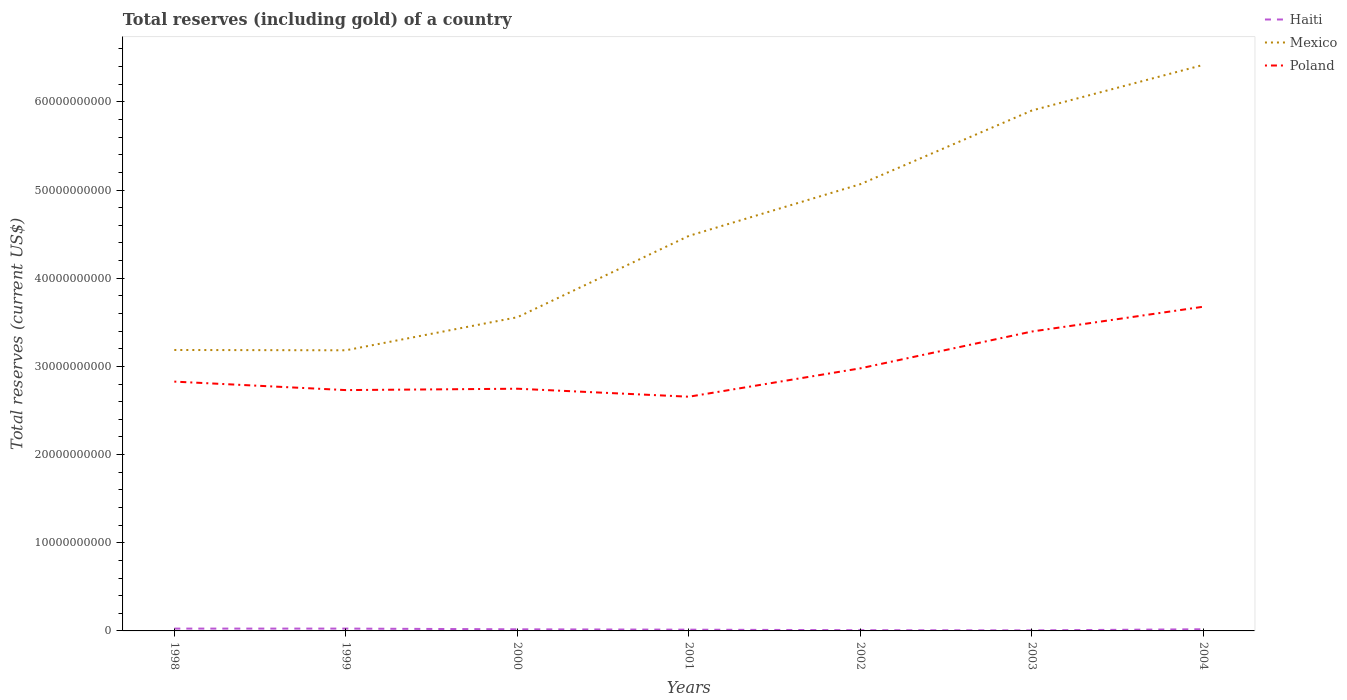Does the line corresponding to Haiti intersect with the line corresponding to Poland?
Make the answer very short. No. Is the number of lines equal to the number of legend labels?
Provide a succinct answer. Yes. Across all years, what is the maximum total reserves (including gold) in Mexico?
Your response must be concise. 3.18e+1. What is the total total reserves (including gold) in Haiti in the graph?
Give a very brief answer. 1.20e+08. What is the difference between the highest and the second highest total reserves (including gold) in Haiti?
Your answer should be very brief. 2.02e+08. Is the total reserves (including gold) in Mexico strictly greater than the total reserves (including gold) in Poland over the years?
Keep it short and to the point. No. How many years are there in the graph?
Your response must be concise. 7. Does the graph contain grids?
Offer a very short reply. No. Where does the legend appear in the graph?
Your response must be concise. Top right. What is the title of the graph?
Provide a succinct answer. Total reserves (including gold) of a country. What is the label or title of the X-axis?
Offer a very short reply. Years. What is the label or title of the Y-axis?
Keep it short and to the point. Total reserves (current US$). What is the Total reserves (current US$) in Haiti in 1998?
Offer a terse response. 2.64e+08. What is the Total reserves (current US$) of Mexico in 1998?
Your answer should be very brief. 3.19e+1. What is the Total reserves (current US$) in Poland in 1998?
Your response must be concise. 2.83e+1. What is the Total reserves (current US$) of Haiti in 1999?
Provide a succinct answer. 2.64e+08. What is the Total reserves (current US$) of Mexico in 1999?
Give a very brief answer. 3.18e+1. What is the Total reserves (current US$) of Poland in 1999?
Give a very brief answer. 2.73e+1. What is the Total reserves (current US$) in Haiti in 2000?
Ensure brevity in your answer.  1.83e+08. What is the Total reserves (current US$) in Mexico in 2000?
Give a very brief answer. 3.56e+1. What is the Total reserves (current US$) of Poland in 2000?
Keep it short and to the point. 2.75e+1. What is the Total reserves (current US$) in Haiti in 2001?
Offer a terse response. 1.42e+08. What is the Total reserves (current US$) of Mexico in 2001?
Ensure brevity in your answer.  4.48e+1. What is the Total reserves (current US$) of Poland in 2001?
Provide a short and direct response. 2.66e+1. What is the Total reserves (current US$) of Haiti in 2002?
Your answer should be compact. 8.22e+07. What is the Total reserves (current US$) of Mexico in 2002?
Provide a short and direct response. 5.07e+1. What is the Total reserves (current US$) in Poland in 2002?
Provide a short and direct response. 2.98e+1. What is the Total reserves (current US$) of Haiti in 2003?
Give a very brief answer. 6.26e+07. What is the Total reserves (current US$) in Mexico in 2003?
Keep it short and to the point. 5.90e+1. What is the Total reserves (current US$) in Poland in 2003?
Give a very brief answer. 3.40e+1. What is the Total reserves (current US$) of Haiti in 2004?
Provide a short and direct response. 1.89e+08. What is the Total reserves (current US$) in Mexico in 2004?
Keep it short and to the point. 6.42e+1. What is the Total reserves (current US$) in Poland in 2004?
Offer a terse response. 3.68e+1. Across all years, what is the maximum Total reserves (current US$) in Haiti?
Your response must be concise. 2.64e+08. Across all years, what is the maximum Total reserves (current US$) of Mexico?
Your answer should be very brief. 6.42e+1. Across all years, what is the maximum Total reserves (current US$) in Poland?
Provide a succinct answer. 3.68e+1. Across all years, what is the minimum Total reserves (current US$) in Haiti?
Provide a succinct answer. 6.26e+07. Across all years, what is the minimum Total reserves (current US$) of Mexico?
Your answer should be very brief. 3.18e+1. Across all years, what is the minimum Total reserves (current US$) in Poland?
Your response must be concise. 2.66e+1. What is the total Total reserves (current US$) of Haiti in the graph?
Provide a succinct answer. 1.19e+09. What is the total Total reserves (current US$) of Mexico in the graph?
Provide a short and direct response. 3.18e+11. What is the total Total reserves (current US$) of Poland in the graph?
Provide a succinct answer. 2.10e+11. What is the difference between the Total reserves (current US$) of Haiti in 1998 and that in 1999?
Your answer should be very brief. -4.88e+05. What is the difference between the Total reserves (current US$) of Mexico in 1998 and that in 1999?
Provide a short and direct response. 3.48e+07. What is the difference between the Total reserves (current US$) in Poland in 1998 and that in 1999?
Your response must be concise. 9.62e+08. What is the difference between the Total reserves (current US$) in Haiti in 1998 and that in 2000?
Keep it short and to the point. 8.14e+07. What is the difference between the Total reserves (current US$) in Mexico in 1998 and that in 2000?
Keep it short and to the point. -3.71e+09. What is the difference between the Total reserves (current US$) of Poland in 1998 and that in 2000?
Ensure brevity in your answer.  8.07e+08. What is the difference between the Total reserves (current US$) in Haiti in 1998 and that in 2001?
Offer a terse response. 1.22e+08. What is the difference between the Total reserves (current US$) in Mexico in 1998 and that in 2001?
Provide a short and direct response. -1.29e+1. What is the difference between the Total reserves (current US$) of Poland in 1998 and that in 2001?
Your answer should be very brief. 1.71e+09. What is the difference between the Total reserves (current US$) in Haiti in 1998 and that in 2002?
Your answer should be very brief. 1.82e+08. What is the difference between the Total reserves (current US$) in Mexico in 1998 and that in 2002?
Offer a terse response. -1.88e+1. What is the difference between the Total reserves (current US$) of Poland in 1998 and that in 2002?
Give a very brief answer. -1.51e+09. What is the difference between the Total reserves (current US$) in Haiti in 1998 and that in 2003?
Your answer should be compact. 2.01e+08. What is the difference between the Total reserves (current US$) of Mexico in 1998 and that in 2003?
Your answer should be compact. -2.72e+1. What is the difference between the Total reserves (current US$) of Poland in 1998 and that in 2003?
Your answer should be very brief. -5.68e+09. What is the difference between the Total reserves (current US$) in Haiti in 1998 and that in 2004?
Make the answer very short. 7.49e+07. What is the difference between the Total reserves (current US$) of Mexico in 1998 and that in 2004?
Make the answer very short. -3.23e+1. What is the difference between the Total reserves (current US$) in Poland in 1998 and that in 2004?
Ensure brevity in your answer.  -8.50e+09. What is the difference between the Total reserves (current US$) in Haiti in 1999 and that in 2000?
Your response must be concise. 8.19e+07. What is the difference between the Total reserves (current US$) in Mexico in 1999 and that in 2000?
Keep it short and to the point. -3.75e+09. What is the difference between the Total reserves (current US$) in Poland in 1999 and that in 2000?
Your response must be concise. -1.55e+08. What is the difference between the Total reserves (current US$) of Haiti in 1999 and that in 2001?
Give a very brief answer. 1.23e+08. What is the difference between the Total reserves (current US$) in Mexico in 1999 and that in 2001?
Your response must be concise. -1.30e+1. What is the difference between the Total reserves (current US$) in Poland in 1999 and that in 2001?
Your response must be concise. 7.51e+08. What is the difference between the Total reserves (current US$) of Haiti in 1999 and that in 2002?
Your answer should be compact. 1.82e+08. What is the difference between the Total reserves (current US$) in Mexico in 1999 and that in 2002?
Keep it short and to the point. -1.88e+1. What is the difference between the Total reserves (current US$) of Poland in 1999 and that in 2002?
Offer a very short reply. -2.47e+09. What is the difference between the Total reserves (current US$) of Haiti in 1999 and that in 2003?
Make the answer very short. 2.02e+08. What is the difference between the Total reserves (current US$) in Mexico in 1999 and that in 2003?
Your response must be concise. -2.72e+1. What is the difference between the Total reserves (current US$) in Poland in 1999 and that in 2003?
Offer a terse response. -6.64e+09. What is the difference between the Total reserves (current US$) in Haiti in 1999 and that in 2004?
Make the answer very short. 7.54e+07. What is the difference between the Total reserves (current US$) in Mexico in 1999 and that in 2004?
Your response must be concise. -3.24e+1. What is the difference between the Total reserves (current US$) of Poland in 1999 and that in 2004?
Your response must be concise. -9.46e+09. What is the difference between the Total reserves (current US$) in Haiti in 2000 and that in 2001?
Offer a terse response. 4.07e+07. What is the difference between the Total reserves (current US$) of Mexico in 2000 and that in 2001?
Your answer should be very brief. -9.23e+09. What is the difference between the Total reserves (current US$) in Poland in 2000 and that in 2001?
Provide a short and direct response. 9.06e+08. What is the difference between the Total reserves (current US$) in Haiti in 2000 and that in 2002?
Your answer should be very brief. 1.00e+08. What is the difference between the Total reserves (current US$) in Mexico in 2000 and that in 2002?
Ensure brevity in your answer.  -1.51e+1. What is the difference between the Total reserves (current US$) in Poland in 2000 and that in 2002?
Provide a succinct answer. -2.31e+09. What is the difference between the Total reserves (current US$) in Haiti in 2000 and that in 2003?
Make the answer very short. 1.20e+08. What is the difference between the Total reserves (current US$) of Mexico in 2000 and that in 2003?
Your answer should be very brief. -2.34e+1. What is the difference between the Total reserves (current US$) in Poland in 2000 and that in 2003?
Your response must be concise. -6.49e+09. What is the difference between the Total reserves (current US$) in Haiti in 2000 and that in 2004?
Your answer should be very brief. -6.56e+06. What is the difference between the Total reserves (current US$) of Mexico in 2000 and that in 2004?
Provide a short and direct response. -2.86e+1. What is the difference between the Total reserves (current US$) in Poland in 2000 and that in 2004?
Your answer should be very brief. -9.30e+09. What is the difference between the Total reserves (current US$) of Haiti in 2001 and that in 2002?
Offer a very short reply. 5.96e+07. What is the difference between the Total reserves (current US$) of Mexico in 2001 and that in 2002?
Keep it short and to the point. -5.87e+09. What is the difference between the Total reserves (current US$) in Poland in 2001 and that in 2002?
Your answer should be very brief. -3.22e+09. What is the difference between the Total reserves (current US$) of Haiti in 2001 and that in 2003?
Ensure brevity in your answer.  7.92e+07. What is the difference between the Total reserves (current US$) of Mexico in 2001 and that in 2003?
Your response must be concise. -1.42e+1. What is the difference between the Total reserves (current US$) of Poland in 2001 and that in 2003?
Keep it short and to the point. -7.40e+09. What is the difference between the Total reserves (current US$) of Haiti in 2001 and that in 2004?
Your answer should be compact. -4.73e+07. What is the difference between the Total reserves (current US$) of Mexico in 2001 and that in 2004?
Offer a very short reply. -1.94e+1. What is the difference between the Total reserves (current US$) of Poland in 2001 and that in 2004?
Provide a succinct answer. -1.02e+1. What is the difference between the Total reserves (current US$) of Haiti in 2002 and that in 2003?
Give a very brief answer. 1.96e+07. What is the difference between the Total reserves (current US$) of Mexico in 2002 and that in 2003?
Your answer should be very brief. -8.36e+09. What is the difference between the Total reserves (current US$) of Poland in 2002 and that in 2003?
Make the answer very short. -4.18e+09. What is the difference between the Total reserves (current US$) of Haiti in 2002 and that in 2004?
Provide a short and direct response. -1.07e+08. What is the difference between the Total reserves (current US$) of Mexico in 2002 and that in 2004?
Your answer should be compact. -1.35e+1. What is the difference between the Total reserves (current US$) of Poland in 2002 and that in 2004?
Keep it short and to the point. -6.99e+09. What is the difference between the Total reserves (current US$) in Haiti in 2003 and that in 2004?
Your answer should be compact. -1.26e+08. What is the difference between the Total reserves (current US$) of Mexico in 2003 and that in 2004?
Provide a short and direct response. -5.18e+09. What is the difference between the Total reserves (current US$) in Poland in 2003 and that in 2004?
Keep it short and to the point. -2.81e+09. What is the difference between the Total reserves (current US$) of Haiti in 1998 and the Total reserves (current US$) of Mexico in 1999?
Ensure brevity in your answer.  -3.16e+1. What is the difference between the Total reserves (current US$) of Haiti in 1998 and the Total reserves (current US$) of Poland in 1999?
Make the answer very short. -2.71e+1. What is the difference between the Total reserves (current US$) in Mexico in 1998 and the Total reserves (current US$) in Poland in 1999?
Your answer should be very brief. 4.55e+09. What is the difference between the Total reserves (current US$) in Haiti in 1998 and the Total reserves (current US$) in Mexico in 2000?
Keep it short and to the point. -3.53e+1. What is the difference between the Total reserves (current US$) in Haiti in 1998 and the Total reserves (current US$) in Poland in 2000?
Give a very brief answer. -2.72e+1. What is the difference between the Total reserves (current US$) of Mexico in 1998 and the Total reserves (current US$) of Poland in 2000?
Your answer should be very brief. 4.39e+09. What is the difference between the Total reserves (current US$) in Haiti in 1998 and the Total reserves (current US$) in Mexico in 2001?
Make the answer very short. -4.45e+1. What is the difference between the Total reserves (current US$) of Haiti in 1998 and the Total reserves (current US$) of Poland in 2001?
Offer a terse response. -2.63e+1. What is the difference between the Total reserves (current US$) in Mexico in 1998 and the Total reserves (current US$) in Poland in 2001?
Give a very brief answer. 5.30e+09. What is the difference between the Total reserves (current US$) of Haiti in 1998 and the Total reserves (current US$) of Mexico in 2002?
Make the answer very short. -5.04e+1. What is the difference between the Total reserves (current US$) of Haiti in 1998 and the Total reserves (current US$) of Poland in 2002?
Provide a succinct answer. -2.95e+1. What is the difference between the Total reserves (current US$) of Mexico in 1998 and the Total reserves (current US$) of Poland in 2002?
Your answer should be very brief. 2.08e+09. What is the difference between the Total reserves (current US$) in Haiti in 1998 and the Total reserves (current US$) in Mexico in 2003?
Ensure brevity in your answer.  -5.88e+1. What is the difference between the Total reserves (current US$) of Haiti in 1998 and the Total reserves (current US$) of Poland in 2003?
Give a very brief answer. -3.37e+1. What is the difference between the Total reserves (current US$) of Mexico in 1998 and the Total reserves (current US$) of Poland in 2003?
Your response must be concise. -2.10e+09. What is the difference between the Total reserves (current US$) in Haiti in 1998 and the Total reserves (current US$) in Mexico in 2004?
Provide a short and direct response. -6.39e+1. What is the difference between the Total reserves (current US$) of Haiti in 1998 and the Total reserves (current US$) of Poland in 2004?
Your answer should be compact. -3.65e+1. What is the difference between the Total reserves (current US$) of Mexico in 1998 and the Total reserves (current US$) of Poland in 2004?
Offer a very short reply. -4.91e+09. What is the difference between the Total reserves (current US$) of Haiti in 1999 and the Total reserves (current US$) of Mexico in 2000?
Ensure brevity in your answer.  -3.53e+1. What is the difference between the Total reserves (current US$) in Haiti in 1999 and the Total reserves (current US$) in Poland in 2000?
Provide a succinct answer. -2.72e+1. What is the difference between the Total reserves (current US$) in Mexico in 1999 and the Total reserves (current US$) in Poland in 2000?
Offer a terse response. 4.36e+09. What is the difference between the Total reserves (current US$) in Haiti in 1999 and the Total reserves (current US$) in Mexico in 2001?
Your answer should be compact. -4.45e+1. What is the difference between the Total reserves (current US$) in Haiti in 1999 and the Total reserves (current US$) in Poland in 2001?
Your answer should be very brief. -2.63e+1. What is the difference between the Total reserves (current US$) of Mexico in 1999 and the Total reserves (current US$) of Poland in 2001?
Your answer should be compact. 5.27e+09. What is the difference between the Total reserves (current US$) in Haiti in 1999 and the Total reserves (current US$) in Mexico in 2002?
Your response must be concise. -5.04e+1. What is the difference between the Total reserves (current US$) in Haiti in 1999 and the Total reserves (current US$) in Poland in 2002?
Your response must be concise. -2.95e+1. What is the difference between the Total reserves (current US$) of Mexico in 1999 and the Total reserves (current US$) of Poland in 2002?
Give a very brief answer. 2.04e+09. What is the difference between the Total reserves (current US$) in Haiti in 1999 and the Total reserves (current US$) in Mexico in 2003?
Provide a short and direct response. -5.88e+1. What is the difference between the Total reserves (current US$) of Haiti in 1999 and the Total reserves (current US$) of Poland in 2003?
Offer a very short reply. -3.37e+1. What is the difference between the Total reserves (current US$) of Mexico in 1999 and the Total reserves (current US$) of Poland in 2003?
Ensure brevity in your answer.  -2.13e+09. What is the difference between the Total reserves (current US$) in Haiti in 1999 and the Total reserves (current US$) in Mexico in 2004?
Keep it short and to the point. -6.39e+1. What is the difference between the Total reserves (current US$) in Haiti in 1999 and the Total reserves (current US$) in Poland in 2004?
Offer a very short reply. -3.65e+1. What is the difference between the Total reserves (current US$) in Mexico in 1999 and the Total reserves (current US$) in Poland in 2004?
Make the answer very short. -4.94e+09. What is the difference between the Total reserves (current US$) in Haiti in 2000 and the Total reserves (current US$) in Mexico in 2001?
Your answer should be compact. -4.46e+1. What is the difference between the Total reserves (current US$) in Haiti in 2000 and the Total reserves (current US$) in Poland in 2001?
Ensure brevity in your answer.  -2.64e+1. What is the difference between the Total reserves (current US$) of Mexico in 2000 and the Total reserves (current US$) of Poland in 2001?
Your response must be concise. 9.01e+09. What is the difference between the Total reserves (current US$) in Haiti in 2000 and the Total reserves (current US$) in Mexico in 2002?
Your answer should be compact. -5.05e+1. What is the difference between the Total reserves (current US$) in Haiti in 2000 and the Total reserves (current US$) in Poland in 2002?
Give a very brief answer. -2.96e+1. What is the difference between the Total reserves (current US$) in Mexico in 2000 and the Total reserves (current US$) in Poland in 2002?
Provide a succinct answer. 5.79e+09. What is the difference between the Total reserves (current US$) of Haiti in 2000 and the Total reserves (current US$) of Mexico in 2003?
Provide a short and direct response. -5.88e+1. What is the difference between the Total reserves (current US$) of Haiti in 2000 and the Total reserves (current US$) of Poland in 2003?
Make the answer very short. -3.38e+1. What is the difference between the Total reserves (current US$) in Mexico in 2000 and the Total reserves (current US$) in Poland in 2003?
Give a very brief answer. 1.62e+09. What is the difference between the Total reserves (current US$) in Haiti in 2000 and the Total reserves (current US$) in Mexico in 2004?
Ensure brevity in your answer.  -6.40e+1. What is the difference between the Total reserves (current US$) in Haiti in 2000 and the Total reserves (current US$) in Poland in 2004?
Keep it short and to the point. -3.66e+1. What is the difference between the Total reserves (current US$) in Mexico in 2000 and the Total reserves (current US$) in Poland in 2004?
Make the answer very short. -1.20e+09. What is the difference between the Total reserves (current US$) of Haiti in 2001 and the Total reserves (current US$) of Mexico in 2002?
Provide a succinct answer. -5.05e+1. What is the difference between the Total reserves (current US$) of Haiti in 2001 and the Total reserves (current US$) of Poland in 2002?
Offer a very short reply. -2.96e+1. What is the difference between the Total reserves (current US$) of Mexico in 2001 and the Total reserves (current US$) of Poland in 2002?
Your response must be concise. 1.50e+1. What is the difference between the Total reserves (current US$) in Haiti in 2001 and the Total reserves (current US$) in Mexico in 2003?
Offer a very short reply. -5.89e+1. What is the difference between the Total reserves (current US$) in Haiti in 2001 and the Total reserves (current US$) in Poland in 2003?
Keep it short and to the point. -3.38e+1. What is the difference between the Total reserves (current US$) in Mexico in 2001 and the Total reserves (current US$) in Poland in 2003?
Your answer should be compact. 1.08e+1. What is the difference between the Total reserves (current US$) in Haiti in 2001 and the Total reserves (current US$) in Mexico in 2004?
Offer a very short reply. -6.41e+1. What is the difference between the Total reserves (current US$) in Haiti in 2001 and the Total reserves (current US$) in Poland in 2004?
Your answer should be compact. -3.66e+1. What is the difference between the Total reserves (current US$) in Mexico in 2001 and the Total reserves (current US$) in Poland in 2004?
Your response must be concise. 8.03e+09. What is the difference between the Total reserves (current US$) of Haiti in 2002 and the Total reserves (current US$) of Mexico in 2003?
Offer a terse response. -5.89e+1. What is the difference between the Total reserves (current US$) of Haiti in 2002 and the Total reserves (current US$) of Poland in 2003?
Your answer should be compact. -3.39e+1. What is the difference between the Total reserves (current US$) in Mexico in 2002 and the Total reserves (current US$) in Poland in 2003?
Keep it short and to the point. 1.67e+1. What is the difference between the Total reserves (current US$) of Haiti in 2002 and the Total reserves (current US$) of Mexico in 2004?
Provide a succinct answer. -6.41e+1. What is the difference between the Total reserves (current US$) of Haiti in 2002 and the Total reserves (current US$) of Poland in 2004?
Keep it short and to the point. -3.67e+1. What is the difference between the Total reserves (current US$) of Mexico in 2002 and the Total reserves (current US$) of Poland in 2004?
Offer a terse response. 1.39e+1. What is the difference between the Total reserves (current US$) in Haiti in 2003 and the Total reserves (current US$) in Mexico in 2004?
Provide a succinct answer. -6.41e+1. What is the difference between the Total reserves (current US$) of Haiti in 2003 and the Total reserves (current US$) of Poland in 2004?
Give a very brief answer. -3.67e+1. What is the difference between the Total reserves (current US$) of Mexico in 2003 and the Total reserves (current US$) of Poland in 2004?
Provide a succinct answer. 2.23e+1. What is the average Total reserves (current US$) in Haiti per year?
Your response must be concise. 1.69e+08. What is the average Total reserves (current US$) of Mexico per year?
Your answer should be very brief. 4.54e+1. What is the average Total reserves (current US$) of Poland per year?
Your response must be concise. 3.00e+1. In the year 1998, what is the difference between the Total reserves (current US$) of Haiti and Total reserves (current US$) of Mexico?
Provide a short and direct response. -3.16e+1. In the year 1998, what is the difference between the Total reserves (current US$) in Haiti and Total reserves (current US$) in Poland?
Your answer should be compact. -2.80e+1. In the year 1998, what is the difference between the Total reserves (current US$) in Mexico and Total reserves (current US$) in Poland?
Keep it short and to the point. 3.59e+09. In the year 1999, what is the difference between the Total reserves (current US$) in Haiti and Total reserves (current US$) in Mexico?
Make the answer very short. -3.16e+1. In the year 1999, what is the difference between the Total reserves (current US$) of Haiti and Total reserves (current US$) of Poland?
Your answer should be compact. -2.70e+1. In the year 1999, what is the difference between the Total reserves (current US$) in Mexico and Total reserves (current US$) in Poland?
Your answer should be compact. 4.51e+09. In the year 2000, what is the difference between the Total reserves (current US$) of Haiti and Total reserves (current US$) of Mexico?
Provide a succinct answer. -3.54e+1. In the year 2000, what is the difference between the Total reserves (current US$) of Haiti and Total reserves (current US$) of Poland?
Provide a succinct answer. -2.73e+1. In the year 2000, what is the difference between the Total reserves (current US$) of Mexico and Total reserves (current US$) of Poland?
Provide a short and direct response. 8.11e+09. In the year 2001, what is the difference between the Total reserves (current US$) in Haiti and Total reserves (current US$) in Mexico?
Your response must be concise. -4.47e+1. In the year 2001, what is the difference between the Total reserves (current US$) in Haiti and Total reserves (current US$) in Poland?
Your answer should be compact. -2.64e+1. In the year 2001, what is the difference between the Total reserves (current US$) in Mexico and Total reserves (current US$) in Poland?
Keep it short and to the point. 1.82e+1. In the year 2002, what is the difference between the Total reserves (current US$) in Haiti and Total reserves (current US$) in Mexico?
Provide a succinct answer. -5.06e+1. In the year 2002, what is the difference between the Total reserves (current US$) in Haiti and Total reserves (current US$) in Poland?
Your answer should be very brief. -2.97e+1. In the year 2002, what is the difference between the Total reserves (current US$) in Mexico and Total reserves (current US$) in Poland?
Your answer should be very brief. 2.09e+1. In the year 2003, what is the difference between the Total reserves (current US$) in Haiti and Total reserves (current US$) in Mexico?
Make the answer very short. -5.90e+1. In the year 2003, what is the difference between the Total reserves (current US$) of Haiti and Total reserves (current US$) of Poland?
Your answer should be very brief. -3.39e+1. In the year 2003, what is the difference between the Total reserves (current US$) of Mexico and Total reserves (current US$) of Poland?
Offer a very short reply. 2.51e+1. In the year 2004, what is the difference between the Total reserves (current US$) in Haiti and Total reserves (current US$) in Mexico?
Provide a succinct answer. -6.40e+1. In the year 2004, what is the difference between the Total reserves (current US$) of Haiti and Total reserves (current US$) of Poland?
Make the answer very short. -3.66e+1. In the year 2004, what is the difference between the Total reserves (current US$) in Mexico and Total reserves (current US$) in Poland?
Keep it short and to the point. 2.74e+1. What is the ratio of the Total reserves (current US$) of Haiti in 1998 to that in 1999?
Keep it short and to the point. 1. What is the ratio of the Total reserves (current US$) in Poland in 1998 to that in 1999?
Your answer should be compact. 1.04. What is the ratio of the Total reserves (current US$) of Haiti in 1998 to that in 2000?
Your response must be concise. 1.45. What is the ratio of the Total reserves (current US$) of Mexico in 1998 to that in 2000?
Keep it short and to the point. 0.9. What is the ratio of the Total reserves (current US$) in Poland in 1998 to that in 2000?
Ensure brevity in your answer.  1.03. What is the ratio of the Total reserves (current US$) of Haiti in 1998 to that in 2001?
Give a very brief answer. 1.86. What is the ratio of the Total reserves (current US$) of Mexico in 1998 to that in 2001?
Your answer should be very brief. 0.71. What is the ratio of the Total reserves (current US$) in Poland in 1998 to that in 2001?
Provide a succinct answer. 1.06. What is the ratio of the Total reserves (current US$) of Haiti in 1998 to that in 2002?
Offer a very short reply. 3.21. What is the ratio of the Total reserves (current US$) of Mexico in 1998 to that in 2002?
Your response must be concise. 0.63. What is the ratio of the Total reserves (current US$) of Poland in 1998 to that in 2002?
Provide a short and direct response. 0.95. What is the ratio of the Total reserves (current US$) in Haiti in 1998 to that in 2003?
Give a very brief answer. 4.22. What is the ratio of the Total reserves (current US$) of Mexico in 1998 to that in 2003?
Offer a very short reply. 0.54. What is the ratio of the Total reserves (current US$) of Poland in 1998 to that in 2003?
Provide a short and direct response. 0.83. What is the ratio of the Total reserves (current US$) in Haiti in 1998 to that in 2004?
Ensure brevity in your answer.  1.4. What is the ratio of the Total reserves (current US$) of Mexico in 1998 to that in 2004?
Your answer should be very brief. 0.5. What is the ratio of the Total reserves (current US$) in Poland in 1998 to that in 2004?
Offer a very short reply. 0.77. What is the ratio of the Total reserves (current US$) in Haiti in 1999 to that in 2000?
Make the answer very short. 1.45. What is the ratio of the Total reserves (current US$) of Mexico in 1999 to that in 2000?
Offer a terse response. 0.89. What is the ratio of the Total reserves (current US$) of Haiti in 1999 to that in 2001?
Make the answer very short. 1.86. What is the ratio of the Total reserves (current US$) in Mexico in 1999 to that in 2001?
Your response must be concise. 0.71. What is the ratio of the Total reserves (current US$) in Poland in 1999 to that in 2001?
Provide a short and direct response. 1.03. What is the ratio of the Total reserves (current US$) in Haiti in 1999 to that in 2002?
Ensure brevity in your answer.  3.22. What is the ratio of the Total reserves (current US$) in Mexico in 1999 to that in 2002?
Your answer should be very brief. 0.63. What is the ratio of the Total reserves (current US$) in Poland in 1999 to that in 2002?
Keep it short and to the point. 0.92. What is the ratio of the Total reserves (current US$) in Haiti in 1999 to that in 2003?
Your response must be concise. 4.23. What is the ratio of the Total reserves (current US$) of Mexico in 1999 to that in 2003?
Make the answer very short. 0.54. What is the ratio of the Total reserves (current US$) of Poland in 1999 to that in 2003?
Offer a terse response. 0.8. What is the ratio of the Total reserves (current US$) of Haiti in 1999 to that in 2004?
Offer a terse response. 1.4. What is the ratio of the Total reserves (current US$) of Mexico in 1999 to that in 2004?
Your response must be concise. 0.5. What is the ratio of the Total reserves (current US$) of Poland in 1999 to that in 2004?
Your response must be concise. 0.74. What is the ratio of the Total reserves (current US$) in Haiti in 2000 to that in 2001?
Offer a terse response. 1.29. What is the ratio of the Total reserves (current US$) of Mexico in 2000 to that in 2001?
Offer a terse response. 0.79. What is the ratio of the Total reserves (current US$) in Poland in 2000 to that in 2001?
Your response must be concise. 1.03. What is the ratio of the Total reserves (current US$) of Haiti in 2000 to that in 2002?
Your response must be concise. 2.22. What is the ratio of the Total reserves (current US$) in Mexico in 2000 to that in 2002?
Your answer should be compact. 0.7. What is the ratio of the Total reserves (current US$) of Poland in 2000 to that in 2002?
Give a very brief answer. 0.92. What is the ratio of the Total reserves (current US$) in Haiti in 2000 to that in 2003?
Keep it short and to the point. 2.92. What is the ratio of the Total reserves (current US$) of Mexico in 2000 to that in 2003?
Give a very brief answer. 0.6. What is the ratio of the Total reserves (current US$) of Poland in 2000 to that in 2003?
Keep it short and to the point. 0.81. What is the ratio of the Total reserves (current US$) of Haiti in 2000 to that in 2004?
Offer a very short reply. 0.97. What is the ratio of the Total reserves (current US$) of Mexico in 2000 to that in 2004?
Provide a short and direct response. 0.55. What is the ratio of the Total reserves (current US$) of Poland in 2000 to that in 2004?
Give a very brief answer. 0.75. What is the ratio of the Total reserves (current US$) of Haiti in 2001 to that in 2002?
Ensure brevity in your answer.  1.73. What is the ratio of the Total reserves (current US$) in Mexico in 2001 to that in 2002?
Give a very brief answer. 0.88. What is the ratio of the Total reserves (current US$) in Poland in 2001 to that in 2002?
Offer a terse response. 0.89. What is the ratio of the Total reserves (current US$) in Haiti in 2001 to that in 2003?
Offer a very short reply. 2.27. What is the ratio of the Total reserves (current US$) of Mexico in 2001 to that in 2003?
Offer a terse response. 0.76. What is the ratio of the Total reserves (current US$) of Poland in 2001 to that in 2003?
Provide a short and direct response. 0.78. What is the ratio of the Total reserves (current US$) of Haiti in 2001 to that in 2004?
Provide a succinct answer. 0.75. What is the ratio of the Total reserves (current US$) in Mexico in 2001 to that in 2004?
Provide a short and direct response. 0.7. What is the ratio of the Total reserves (current US$) of Poland in 2001 to that in 2004?
Offer a terse response. 0.72. What is the ratio of the Total reserves (current US$) in Haiti in 2002 to that in 2003?
Offer a very short reply. 1.31. What is the ratio of the Total reserves (current US$) in Mexico in 2002 to that in 2003?
Provide a succinct answer. 0.86. What is the ratio of the Total reserves (current US$) of Poland in 2002 to that in 2003?
Provide a short and direct response. 0.88. What is the ratio of the Total reserves (current US$) of Haiti in 2002 to that in 2004?
Offer a terse response. 0.43. What is the ratio of the Total reserves (current US$) in Mexico in 2002 to that in 2004?
Offer a very short reply. 0.79. What is the ratio of the Total reserves (current US$) in Poland in 2002 to that in 2004?
Make the answer very short. 0.81. What is the ratio of the Total reserves (current US$) of Haiti in 2003 to that in 2004?
Provide a short and direct response. 0.33. What is the ratio of the Total reserves (current US$) in Mexico in 2003 to that in 2004?
Ensure brevity in your answer.  0.92. What is the ratio of the Total reserves (current US$) in Poland in 2003 to that in 2004?
Make the answer very short. 0.92. What is the difference between the highest and the second highest Total reserves (current US$) of Haiti?
Offer a very short reply. 4.88e+05. What is the difference between the highest and the second highest Total reserves (current US$) in Mexico?
Provide a succinct answer. 5.18e+09. What is the difference between the highest and the second highest Total reserves (current US$) of Poland?
Your answer should be compact. 2.81e+09. What is the difference between the highest and the lowest Total reserves (current US$) of Haiti?
Make the answer very short. 2.02e+08. What is the difference between the highest and the lowest Total reserves (current US$) of Mexico?
Your answer should be very brief. 3.24e+1. What is the difference between the highest and the lowest Total reserves (current US$) of Poland?
Your answer should be compact. 1.02e+1. 